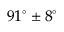<formula> <loc_0><loc_0><loc_500><loc_500>9 1 ^ { \circ } \pm 8 ^ { \circ }</formula> 